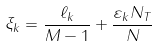Convert formula to latex. <formula><loc_0><loc_0><loc_500><loc_500>\xi _ { k } = \frac { \ell _ { k } } { M - 1 } + \frac { \varepsilon _ { k } N _ { T } } { N }</formula> 